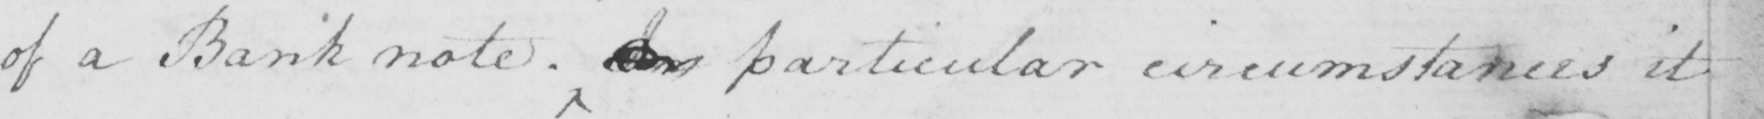Can you tell me what this handwritten text says? of a Bank note .   <gap/>   particular circumstances it 